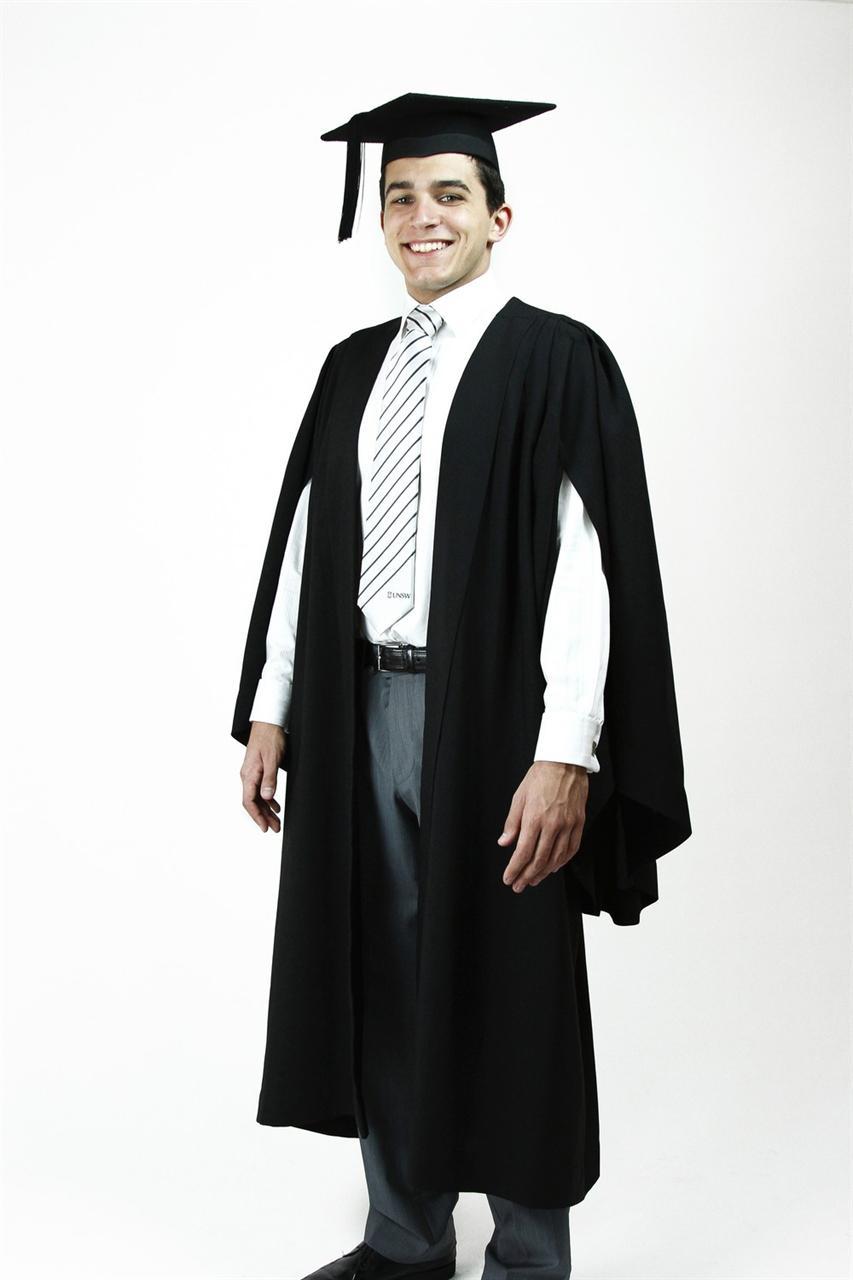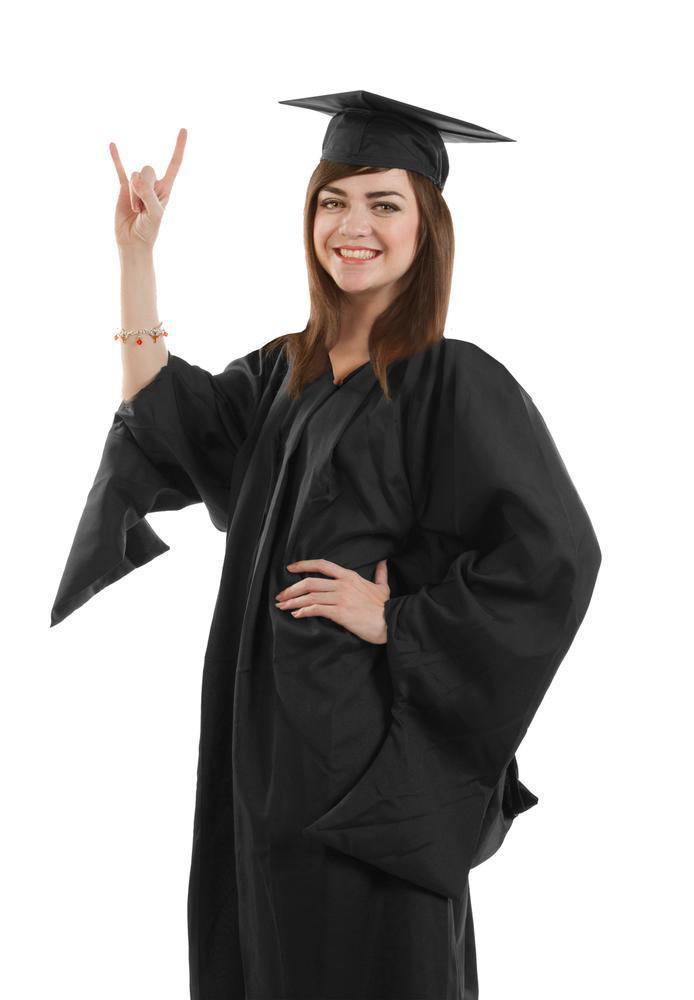The first image is the image on the left, the second image is the image on the right. Considering the images on both sides, is "There is a man on the left and a woman on the right in both images." valid? Answer yes or no. Yes. The first image is the image on the left, the second image is the image on the right. For the images displayed, is the sentence "There is a female in the right image." factually correct? Answer yes or no. Yes. 